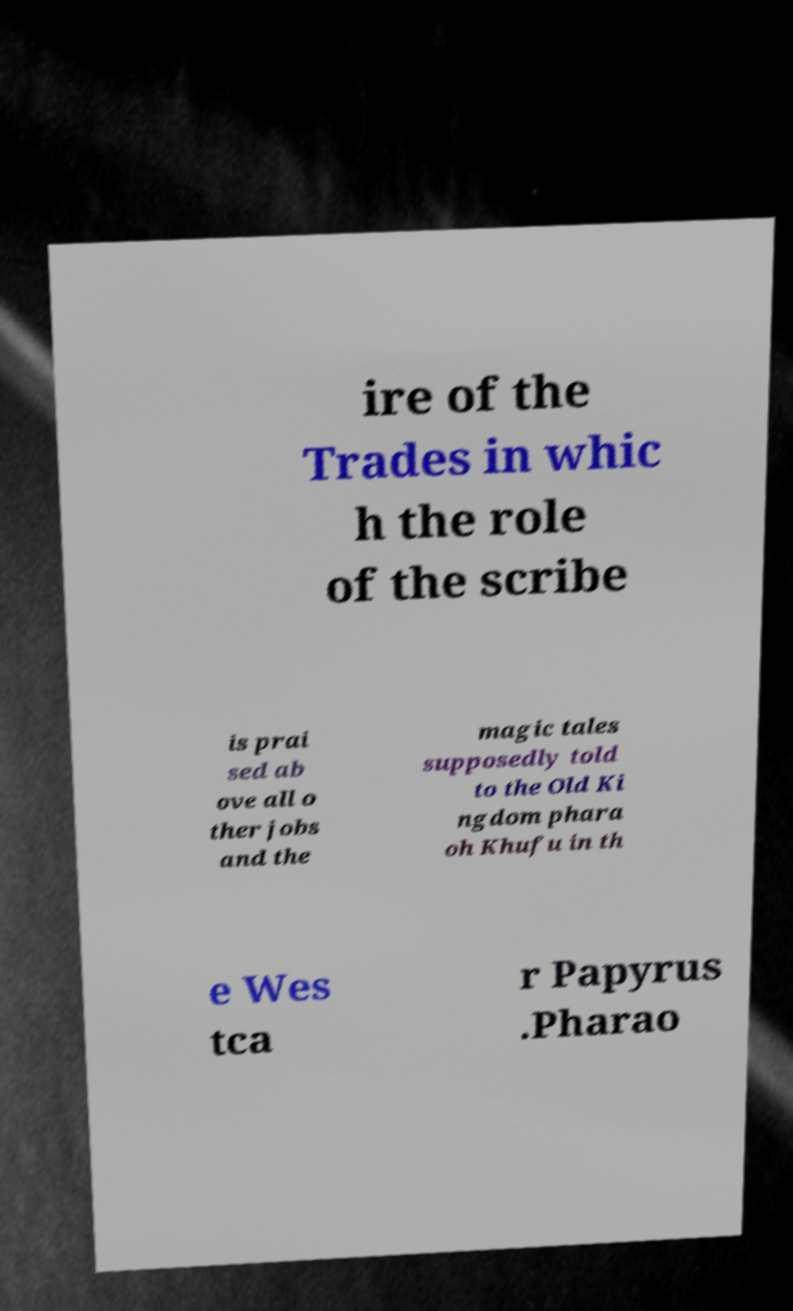Please identify and transcribe the text found in this image. ire of the Trades in whic h the role of the scribe is prai sed ab ove all o ther jobs and the magic tales supposedly told to the Old Ki ngdom phara oh Khufu in th e Wes tca r Papyrus .Pharao 